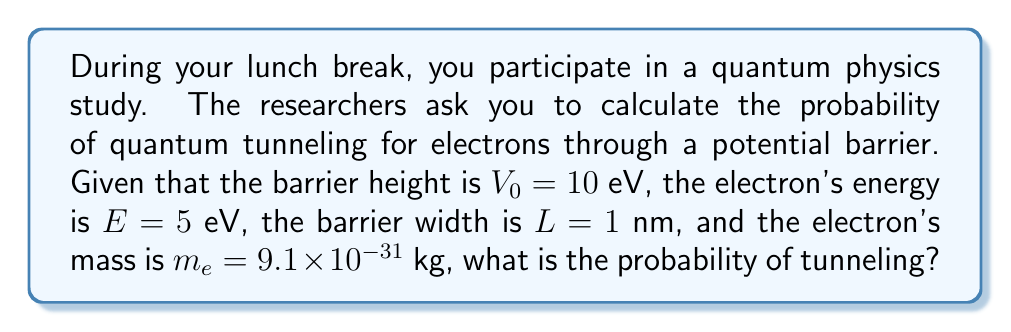Solve this math problem. To solve this problem, we'll use the WKB approximation for quantum tunneling probability:

1) The tunneling probability $T$ is given by:
   $$T \approx e^{-2\gamma}$$
   where $\gamma$ is the Gamow factor.

2) The Gamow factor for a rectangular barrier is:
   $$\gamma = \frac{L}{\hbar}\sqrt{2m_e(V_0 - E)}$$

3) Let's calculate each component:
   - $\hbar = 1.055 \times 10^{-34}$ J·s
   - $L = 1 \text{ nm} = 1 \times 10^{-9}$ m
   - $m_e = 9.1 \times 10^{-31}$ kg
   - $V_0 - E = 10 \text{ eV} - 5 \text{ eV} = 5 \text{ eV} = 8 \times 10^{-19}$ J

4) Substituting these values:
   $$\gamma = \frac{1 \times 10^{-9}}{1.055 \times 10^{-34}}\sqrt{2 \cdot 9.1 \times 10^{-31} \cdot 8 \times 10^{-19}}$$

5) Simplifying:
   $$\gamma \approx 7.46$$

6) Now we can calculate the tunneling probability:
   $$T \approx e^{-2 \cdot 7.46} \approx e^{-14.92} \approx 3.31 \times 10^{-7}$$

7) Converting to a percentage:
   $$T \approx 3.31 \times 10^{-5}\%$$
Answer: $3.31 \times 10^{-5}\%$ 